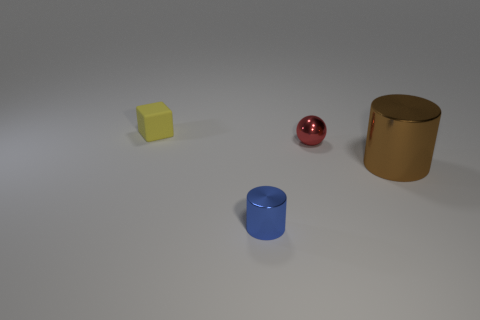Subtract all blue cylinders. How many cylinders are left? 1 Subtract all cyan balls. How many brown cylinders are left? 1 Subtract all cylinders. Subtract all big blocks. How many objects are left? 2 Add 2 small red shiny spheres. How many small red shiny spheres are left? 3 Add 1 large brown metallic balls. How many large brown metallic balls exist? 1 Add 1 tiny blue things. How many objects exist? 5 Subtract 0 purple balls. How many objects are left? 4 Subtract all purple spheres. Subtract all gray cylinders. How many spheres are left? 1 